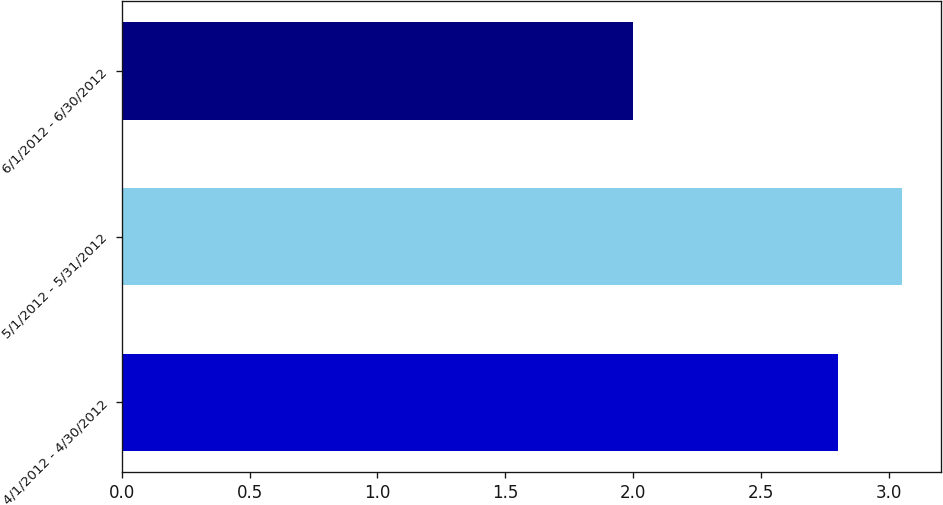Convert chart to OTSL. <chart><loc_0><loc_0><loc_500><loc_500><bar_chart><fcel>4/1/2012 - 4/30/2012<fcel>5/1/2012 - 5/31/2012<fcel>6/1/2012 - 6/30/2012<nl><fcel>2.8<fcel>3.05<fcel>2<nl></chart> 